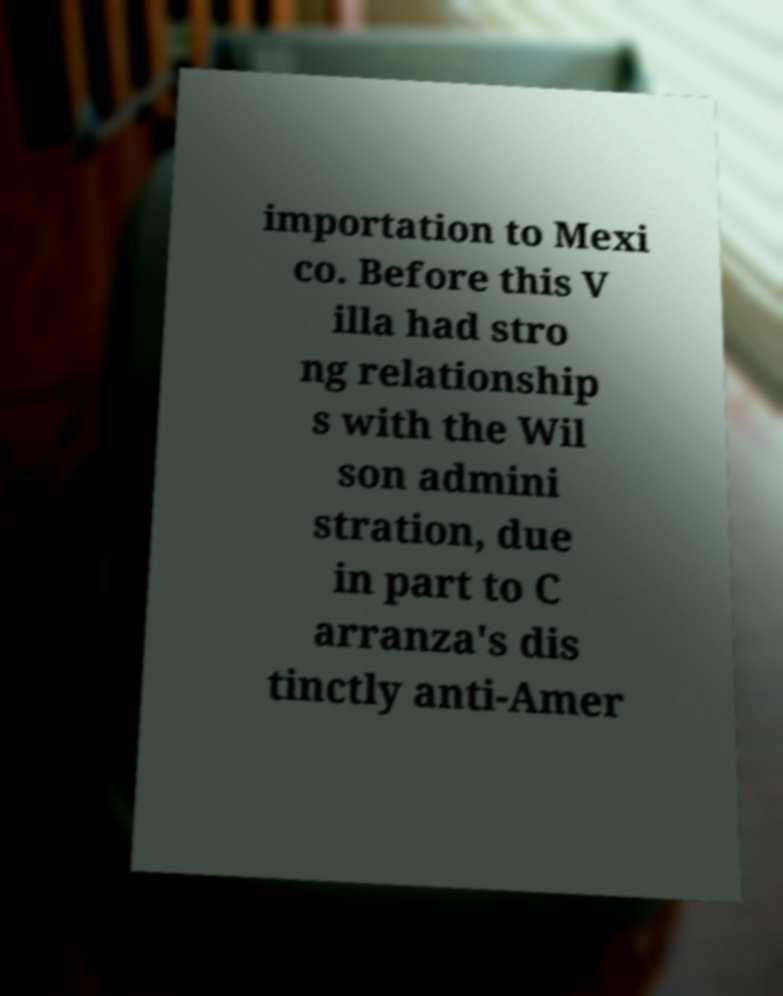Please read and relay the text visible in this image. What does it say? importation to Mexi co. Before this V illa had stro ng relationship s with the Wil son admini stration, due in part to C arranza's dis tinctly anti-Amer 